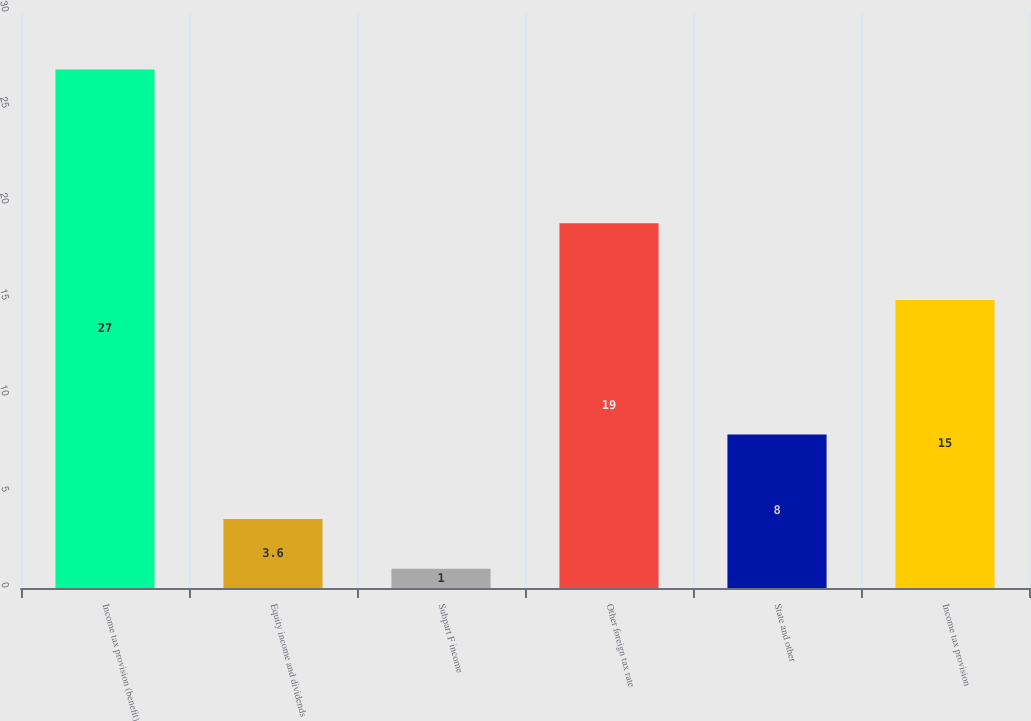Convert chart. <chart><loc_0><loc_0><loc_500><loc_500><bar_chart><fcel>Income tax provision (benefit)<fcel>Equity income and dividends<fcel>Subpart F income<fcel>Other foreign tax rate<fcel>State and other<fcel>Income tax provision<nl><fcel>27<fcel>3.6<fcel>1<fcel>19<fcel>8<fcel>15<nl></chart> 